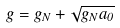Convert formula to latex. <formula><loc_0><loc_0><loc_500><loc_500>g = g _ { N } + \sqrt { g _ { N } a _ { 0 } }</formula> 